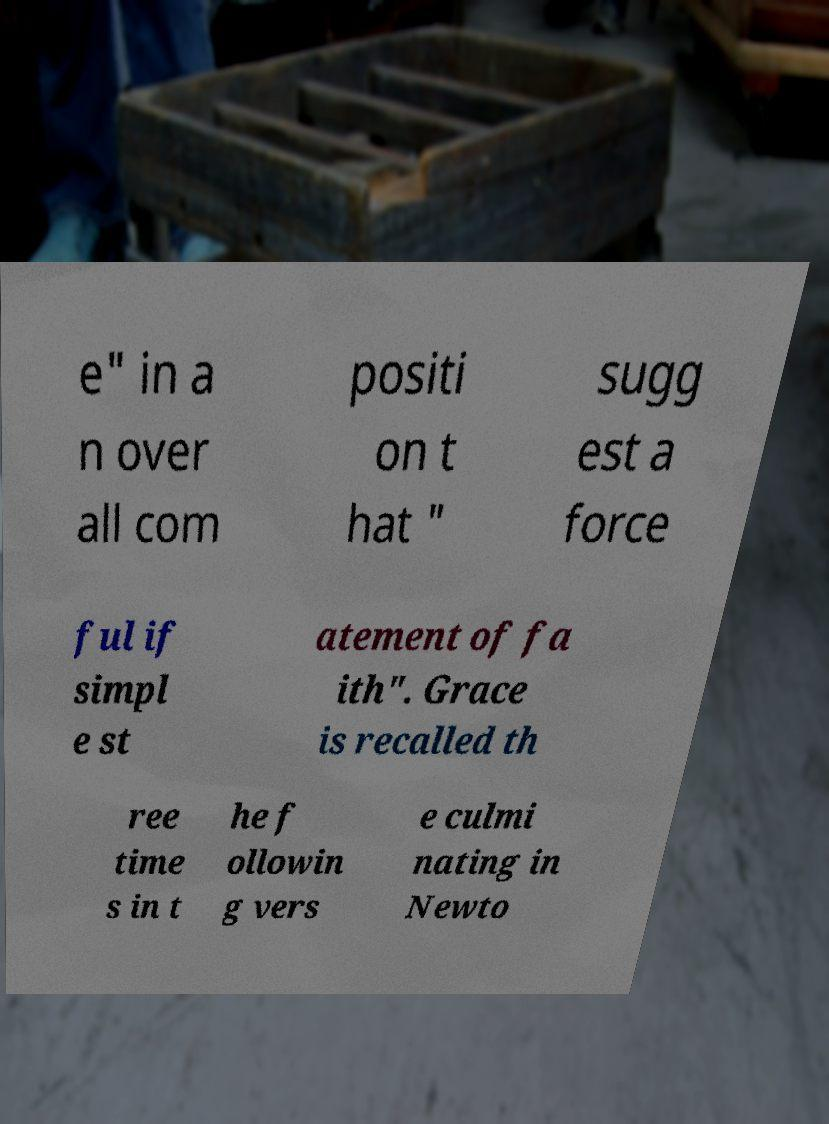Could you extract and type out the text from this image? e" in a n over all com positi on t hat " sugg est a force ful if simpl e st atement of fa ith". Grace is recalled th ree time s in t he f ollowin g vers e culmi nating in Newto 